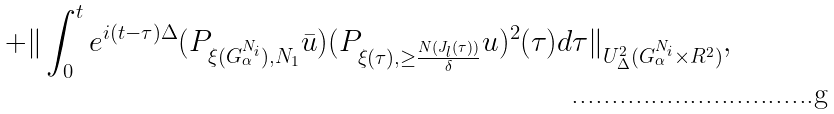Convert formula to latex. <formula><loc_0><loc_0><loc_500><loc_500>+ \| \int _ { 0 } ^ { t } e ^ { i ( t - \tau ) \Delta } ( P _ { \xi ( G _ { \alpha } ^ { N _ { i } } ) , N _ { 1 } } \bar { u } ) ( P _ { \xi ( \tau ) , \geq \frac { N ( J _ { l } ( \tau ) ) } { \delta } } u ) ^ { 2 } ( \tau ) d \tau \| _ { U _ { \Delta } ^ { 2 } ( G _ { \alpha } ^ { N _ { i } } \times R ^ { 2 } ) } ,</formula> 